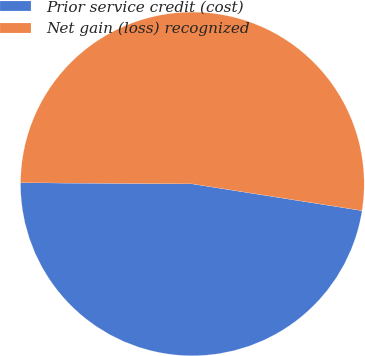Convert chart. <chart><loc_0><loc_0><loc_500><loc_500><pie_chart><fcel>Prior service credit (cost)<fcel>Net gain (loss) recognized<nl><fcel>47.62%<fcel>52.38%<nl></chart> 